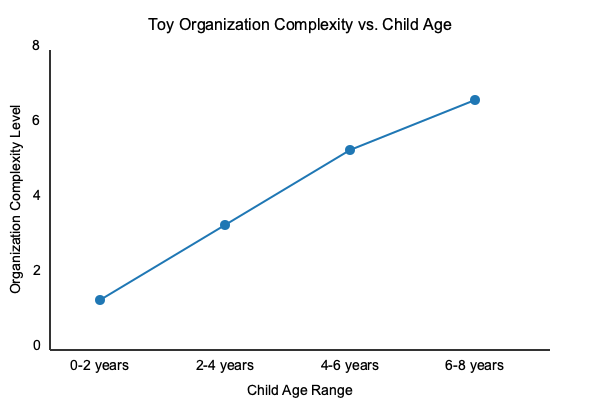Based on the graph showing the relationship between toy organization complexity and child age ranges, what developmental theory best explains the increasing complexity of toy organization systems as children grow older? To answer this question, we need to analyze the graph and connect it to child development theories:

1. The graph shows a clear trend of increasing toy organization complexity as children age.

2. The complexity level starts low for 0-2 years and steadily increases through 6-8 years.

3. This pattern suggests a developmental progression in children's cognitive abilities and organizational skills.

4. The increasing complexity aligns with Piaget's theory of cognitive development:

   a. Sensorimotor stage (0-2 years): Simple organization, mostly done by parents.
   b. Preoperational stage (2-7 years): Increasing ability to categorize and sort.
   c. Concrete operational stage (7-11 years): More advanced organizational skills.

5. Piaget's theory emphasizes that children's cognitive abilities develop in stages, allowing them to understand and interact with their environment in increasingly complex ways.

6. The graph reflects this staged development, showing how toy organization systems can be adapted to match children's growing cognitive abilities.

7. Vygotsky's sociocultural theory also applies, as parents likely scaffold the organization process, gradually increasing complexity as children develop.

8. However, Piaget's theory more directly explains the step-wise increase in organizational complexity shown in the graph.

Therefore, Piaget's theory of cognitive development best explains the increasing complexity of toy organization systems as children grow older, as depicted in the graph.
Answer: Piaget's theory of cognitive development 